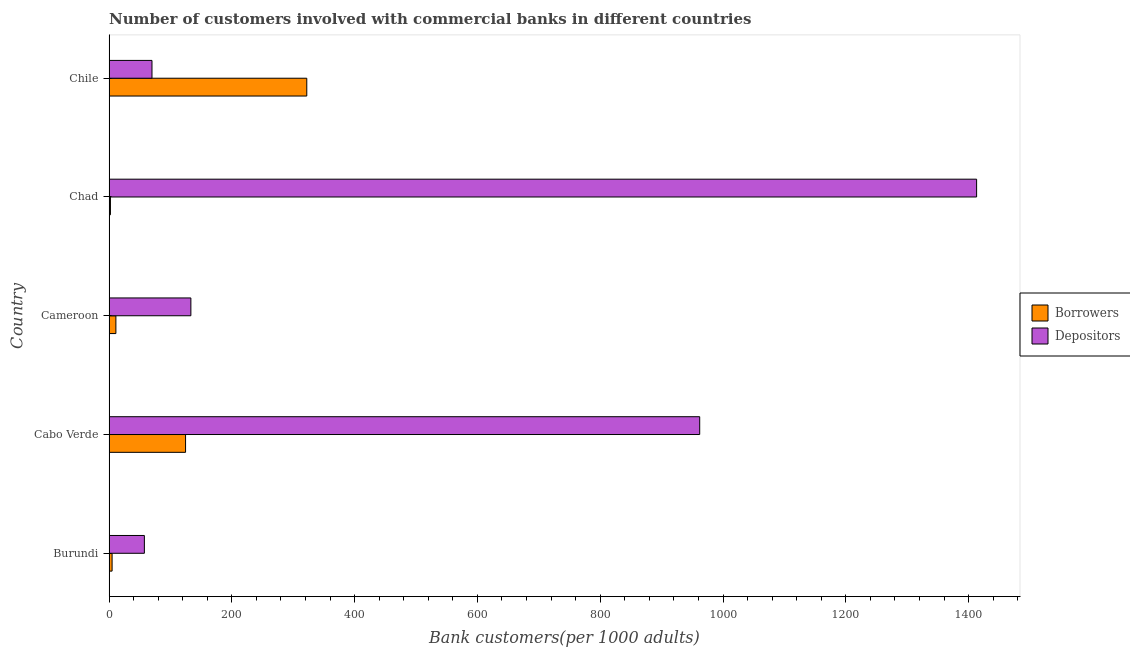How many groups of bars are there?
Provide a succinct answer. 5. Are the number of bars per tick equal to the number of legend labels?
Keep it short and to the point. Yes. What is the label of the 4th group of bars from the top?
Give a very brief answer. Cabo Verde. In how many cases, is the number of bars for a given country not equal to the number of legend labels?
Your response must be concise. 0. What is the number of depositors in Chad?
Give a very brief answer. 1413.08. Across all countries, what is the maximum number of depositors?
Offer a very short reply. 1413.08. Across all countries, what is the minimum number of borrowers?
Make the answer very short. 2.24. In which country was the number of depositors maximum?
Your response must be concise. Chad. In which country was the number of depositors minimum?
Your response must be concise. Burundi. What is the total number of depositors in the graph?
Keep it short and to the point. 2635.8. What is the difference between the number of borrowers in Cabo Verde and that in Cameroon?
Ensure brevity in your answer.  113.5. What is the difference between the number of borrowers in Chile and the number of depositors in Cabo Verde?
Offer a terse response. -640.01. What is the average number of depositors per country?
Provide a succinct answer. 527.16. What is the difference between the number of borrowers and number of depositors in Cameroon?
Offer a terse response. -122.15. In how many countries, is the number of borrowers greater than 1080 ?
Your answer should be very brief. 0. What is the ratio of the number of depositors in Cabo Verde to that in Chad?
Offer a terse response. 0.68. What is the difference between the highest and the second highest number of depositors?
Your answer should be very brief. 451.04. What is the difference between the highest and the lowest number of depositors?
Your response must be concise. 1355.58. In how many countries, is the number of depositors greater than the average number of depositors taken over all countries?
Make the answer very short. 2. Is the sum of the number of borrowers in Burundi and Chile greater than the maximum number of depositors across all countries?
Provide a short and direct response. No. What does the 2nd bar from the top in Chile represents?
Make the answer very short. Borrowers. What does the 2nd bar from the bottom in Cabo Verde represents?
Your answer should be compact. Depositors. Are the values on the major ticks of X-axis written in scientific E-notation?
Offer a very short reply. No. Does the graph contain any zero values?
Give a very brief answer. No. Does the graph contain grids?
Give a very brief answer. No. Where does the legend appear in the graph?
Provide a short and direct response. Center right. How are the legend labels stacked?
Offer a terse response. Vertical. What is the title of the graph?
Offer a terse response. Number of customers involved with commercial banks in different countries. Does "Subsidies" appear as one of the legend labels in the graph?
Your answer should be very brief. No. What is the label or title of the X-axis?
Make the answer very short. Bank customers(per 1000 adults). What is the Bank customers(per 1000 adults) in Borrowers in Burundi?
Keep it short and to the point. 4.94. What is the Bank customers(per 1000 adults) of Depositors in Burundi?
Give a very brief answer. 57.5. What is the Bank customers(per 1000 adults) in Borrowers in Cabo Verde?
Provide a short and direct response. 124.61. What is the Bank customers(per 1000 adults) of Depositors in Cabo Verde?
Keep it short and to the point. 962.05. What is the Bank customers(per 1000 adults) of Borrowers in Cameroon?
Give a very brief answer. 11.11. What is the Bank customers(per 1000 adults) of Depositors in Cameroon?
Provide a succinct answer. 133.26. What is the Bank customers(per 1000 adults) in Borrowers in Chad?
Ensure brevity in your answer.  2.24. What is the Bank customers(per 1000 adults) of Depositors in Chad?
Provide a short and direct response. 1413.08. What is the Bank customers(per 1000 adults) of Borrowers in Chile?
Give a very brief answer. 322.03. What is the Bank customers(per 1000 adults) in Depositors in Chile?
Your answer should be very brief. 69.91. Across all countries, what is the maximum Bank customers(per 1000 adults) in Borrowers?
Ensure brevity in your answer.  322.03. Across all countries, what is the maximum Bank customers(per 1000 adults) of Depositors?
Your response must be concise. 1413.08. Across all countries, what is the minimum Bank customers(per 1000 adults) of Borrowers?
Give a very brief answer. 2.24. Across all countries, what is the minimum Bank customers(per 1000 adults) of Depositors?
Make the answer very short. 57.5. What is the total Bank customers(per 1000 adults) of Borrowers in the graph?
Offer a very short reply. 464.92. What is the total Bank customers(per 1000 adults) of Depositors in the graph?
Provide a short and direct response. 2635.8. What is the difference between the Bank customers(per 1000 adults) in Borrowers in Burundi and that in Cabo Verde?
Your response must be concise. -119.67. What is the difference between the Bank customers(per 1000 adults) of Depositors in Burundi and that in Cabo Verde?
Provide a short and direct response. -904.55. What is the difference between the Bank customers(per 1000 adults) of Borrowers in Burundi and that in Cameroon?
Make the answer very short. -6.16. What is the difference between the Bank customers(per 1000 adults) of Depositors in Burundi and that in Cameroon?
Provide a short and direct response. -75.75. What is the difference between the Bank customers(per 1000 adults) in Borrowers in Burundi and that in Chad?
Your answer should be compact. 2.71. What is the difference between the Bank customers(per 1000 adults) of Depositors in Burundi and that in Chad?
Provide a succinct answer. -1355.58. What is the difference between the Bank customers(per 1000 adults) in Borrowers in Burundi and that in Chile?
Your answer should be very brief. -317.09. What is the difference between the Bank customers(per 1000 adults) in Depositors in Burundi and that in Chile?
Offer a very short reply. -12.41. What is the difference between the Bank customers(per 1000 adults) of Borrowers in Cabo Verde and that in Cameroon?
Your answer should be compact. 113.5. What is the difference between the Bank customers(per 1000 adults) in Depositors in Cabo Verde and that in Cameroon?
Make the answer very short. 828.79. What is the difference between the Bank customers(per 1000 adults) of Borrowers in Cabo Verde and that in Chad?
Offer a very short reply. 122.37. What is the difference between the Bank customers(per 1000 adults) in Depositors in Cabo Verde and that in Chad?
Provide a short and direct response. -451.04. What is the difference between the Bank customers(per 1000 adults) in Borrowers in Cabo Verde and that in Chile?
Offer a terse response. -197.42. What is the difference between the Bank customers(per 1000 adults) of Depositors in Cabo Verde and that in Chile?
Offer a terse response. 892.14. What is the difference between the Bank customers(per 1000 adults) of Borrowers in Cameroon and that in Chad?
Give a very brief answer. 8.87. What is the difference between the Bank customers(per 1000 adults) in Depositors in Cameroon and that in Chad?
Keep it short and to the point. -1279.83. What is the difference between the Bank customers(per 1000 adults) of Borrowers in Cameroon and that in Chile?
Give a very brief answer. -310.93. What is the difference between the Bank customers(per 1000 adults) in Depositors in Cameroon and that in Chile?
Your response must be concise. 63.35. What is the difference between the Bank customers(per 1000 adults) in Borrowers in Chad and that in Chile?
Ensure brevity in your answer.  -319.8. What is the difference between the Bank customers(per 1000 adults) of Depositors in Chad and that in Chile?
Make the answer very short. 1343.17. What is the difference between the Bank customers(per 1000 adults) in Borrowers in Burundi and the Bank customers(per 1000 adults) in Depositors in Cabo Verde?
Your answer should be compact. -957.1. What is the difference between the Bank customers(per 1000 adults) of Borrowers in Burundi and the Bank customers(per 1000 adults) of Depositors in Cameroon?
Offer a terse response. -128.31. What is the difference between the Bank customers(per 1000 adults) of Borrowers in Burundi and the Bank customers(per 1000 adults) of Depositors in Chad?
Your answer should be compact. -1408.14. What is the difference between the Bank customers(per 1000 adults) in Borrowers in Burundi and the Bank customers(per 1000 adults) in Depositors in Chile?
Offer a very short reply. -64.97. What is the difference between the Bank customers(per 1000 adults) in Borrowers in Cabo Verde and the Bank customers(per 1000 adults) in Depositors in Cameroon?
Give a very brief answer. -8.65. What is the difference between the Bank customers(per 1000 adults) of Borrowers in Cabo Verde and the Bank customers(per 1000 adults) of Depositors in Chad?
Your response must be concise. -1288.48. What is the difference between the Bank customers(per 1000 adults) of Borrowers in Cabo Verde and the Bank customers(per 1000 adults) of Depositors in Chile?
Your answer should be compact. 54.7. What is the difference between the Bank customers(per 1000 adults) of Borrowers in Cameroon and the Bank customers(per 1000 adults) of Depositors in Chad?
Provide a succinct answer. -1401.98. What is the difference between the Bank customers(per 1000 adults) in Borrowers in Cameroon and the Bank customers(per 1000 adults) in Depositors in Chile?
Keep it short and to the point. -58.8. What is the difference between the Bank customers(per 1000 adults) in Borrowers in Chad and the Bank customers(per 1000 adults) in Depositors in Chile?
Offer a very short reply. -67.67. What is the average Bank customers(per 1000 adults) of Borrowers per country?
Provide a succinct answer. 92.98. What is the average Bank customers(per 1000 adults) in Depositors per country?
Provide a succinct answer. 527.16. What is the difference between the Bank customers(per 1000 adults) in Borrowers and Bank customers(per 1000 adults) in Depositors in Burundi?
Ensure brevity in your answer.  -52.56. What is the difference between the Bank customers(per 1000 adults) in Borrowers and Bank customers(per 1000 adults) in Depositors in Cabo Verde?
Ensure brevity in your answer.  -837.44. What is the difference between the Bank customers(per 1000 adults) of Borrowers and Bank customers(per 1000 adults) of Depositors in Cameroon?
Offer a terse response. -122.15. What is the difference between the Bank customers(per 1000 adults) in Borrowers and Bank customers(per 1000 adults) in Depositors in Chad?
Your response must be concise. -1410.85. What is the difference between the Bank customers(per 1000 adults) of Borrowers and Bank customers(per 1000 adults) of Depositors in Chile?
Make the answer very short. 252.12. What is the ratio of the Bank customers(per 1000 adults) in Borrowers in Burundi to that in Cabo Verde?
Your answer should be compact. 0.04. What is the ratio of the Bank customers(per 1000 adults) of Depositors in Burundi to that in Cabo Verde?
Provide a short and direct response. 0.06. What is the ratio of the Bank customers(per 1000 adults) in Borrowers in Burundi to that in Cameroon?
Ensure brevity in your answer.  0.45. What is the ratio of the Bank customers(per 1000 adults) of Depositors in Burundi to that in Cameroon?
Provide a short and direct response. 0.43. What is the ratio of the Bank customers(per 1000 adults) of Borrowers in Burundi to that in Chad?
Your response must be concise. 2.21. What is the ratio of the Bank customers(per 1000 adults) in Depositors in Burundi to that in Chad?
Your answer should be very brief. 0.04. What is the ratio of the Bank customers(per 1000 adults) in Borrowers in Burundi to that in Chile?
Provide a succinct answer. 0.02. What is the ratio of the Bank customers(per 1000 adults) in Depositors in Burundi to that in Chile?
Provide a succinct answer. 0.82. What is the ratio of the Bank customers(per 1000 adults) of Borrowers in Cabo Verde to that in Cameroon?
Your answer should be very brief. 11.22. What is the ratio of the Bank customers(per 1000 adults) in Depositors in Cabo Verde to that in Cameroon?
Make the answer very short. 7.22. What is the ratio of the Bank customers(per 1000 adults) of Borrowers in Cabo Verde to that in Chad?
Make the answer very short. 55.73. What is the ratio of the Bank customers(per 1000 adults) of Depositors in Cabo Verde to that in Chad?
Give a very brief answer. 0.68. What is the ratio of the Bank customers(per 1000 adults) of Borrowers in Cabo Verde to that in Chile?
Provide a short and direct response. 0.39. What is the ratio of the Bank customers(per 1000 adults) in Depositors in Cabo Verde to that in Chile?
Give a very brief answer. 13.76. What is the ratio of the Bank customers(per 1000 adults) of Borrowers in Cameroon to that in Chad?
Give a very brief answer. 4.97. What is the ratio of the Bank customers(per 1000 adults) of Depositors in Cameroon to that in Chad?
Your response must be concise. 0.09. What is the ratio of the Bank customers(per 1000 adults) in Borrowers in Cameroon to that in Chile?
Ensure brevity in your answer.  0.03. What is the ratio of the Bank customers(per 1000 adults) in Depositors in Cameroon to that in Chile?
Your response must be concise. 1.91. What is the ratio of the Bank customers(per 1000 adults) of Borrowers in Chad to that in Chile?
Keep it short and to the point. 0.01. What is the ratio of the Bank customers(per 1000 adults) in Depositors in Chad to that in Chile?
Provide a succinct answer. 20.21. What is the difference between the highest and the second highest Bank customers(per 1000 adults) of Borrowers?
Provide a succinct answer. 197.42. What is the difference between the highest and the second highest Bank customers(per 1000 adults) of Depositors?
Your answer should be very brief. 451.04. What is the difference between the highest and the lowest Bank customers(per 1000 adults) in Borrowers?
Keep it short and to the point. 319.8. What is the difference between the highest and the lowest Bank customers(per 1000 adults) in Depositors?
Offer a terse response. 1355.58. 